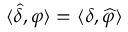<formula> <loc_0><loc_0><loc_500><loc_500>\langle { \widehat { \delta } } , \varphi \rangle = \langle \delta , { \widehat { \varphi } } \rangle</formula> 